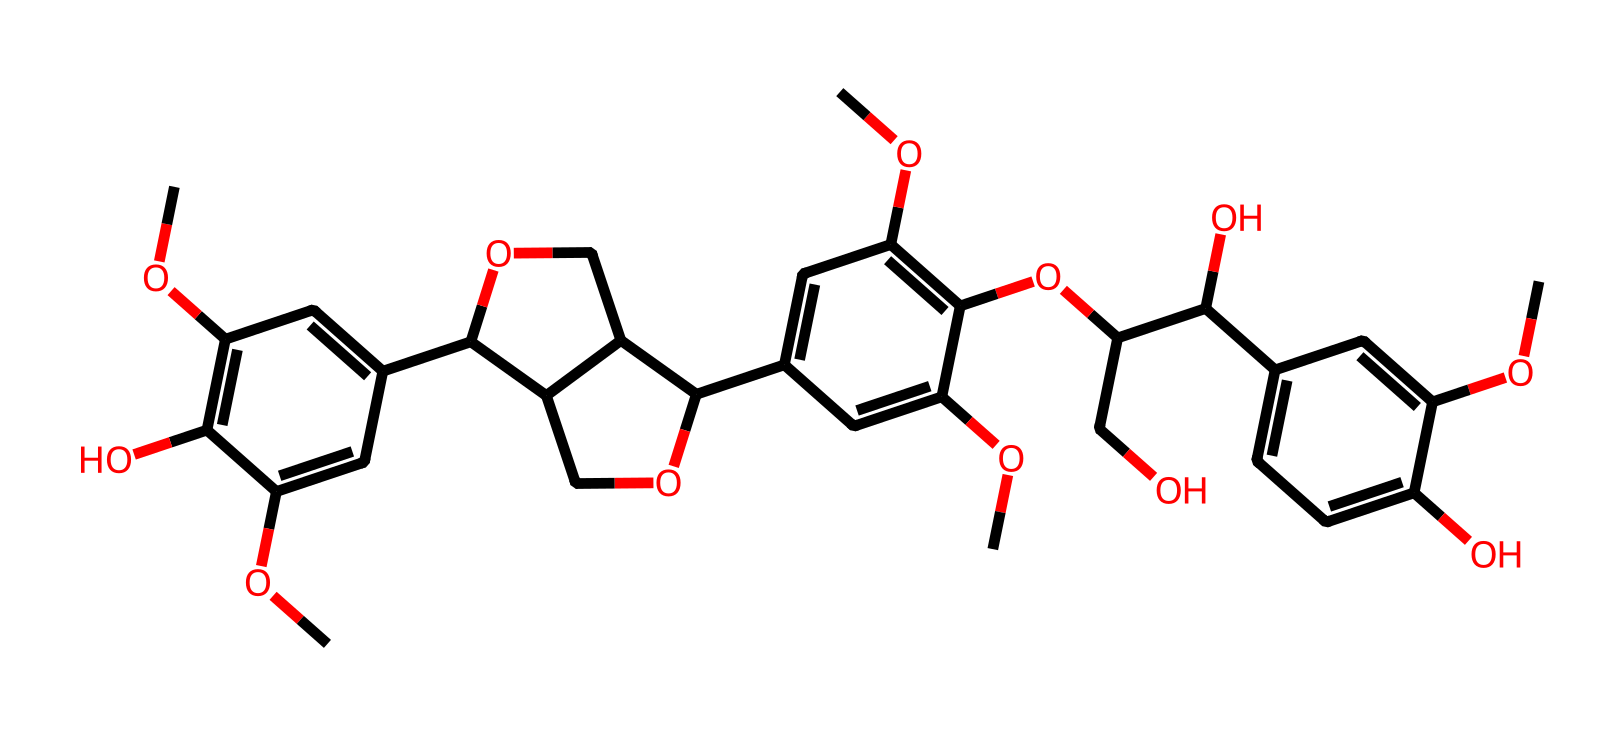What is the total number of carbon atoms in this chemical? By examining the SMILES structure, we can count the number of carbon atoms indicated. Each "C" represents a carbon atom and we can tally them as we parse through the continuous structure. There are a total of 21 carbon atoms.
Answer: 21 How many hydroxyl (OH) groups are present in this compound? Throughout the chemical structure represented, each hydroxyl group is denoted by the "O" connected to a hydrogen "H" (part of the functional group "C(OH)"). We can identify four instances of this configuration in the SMILES string, showing that there are four hydroxyl groups present.
Answer: 4 What functional groups are present in this chemical? In the structure, the hydroxyl groups (–OH) showcase phenolic properties, and the presence of multiple ether groups (–O–) can also be deduced from the connections in the chemical's framework. Therefore, the functional groups consist of hydroxyl and ether groups.
Answer: hydroxyl and ether Which part of the structure is indicative of its phenolic nature? The presence of hydroxyl groups attached directly to the aromatic rings characterizes the compound as a phenol. This can be inferred from observing the structures branching off from the main aromatic cycle. Specifically, the "O" atoms connected to the carbons portray this phenolic feature.
Answer: hydroxyl groups What is the degree of branching in this compound? The SMILES notation indicates several side chains and substituents attached to the main carbon framework. Assessing how many branches emerge from the main structure, we find that there are multiple levels of branching present, indicating it is a highly branched compound.
Answer: highly branched 